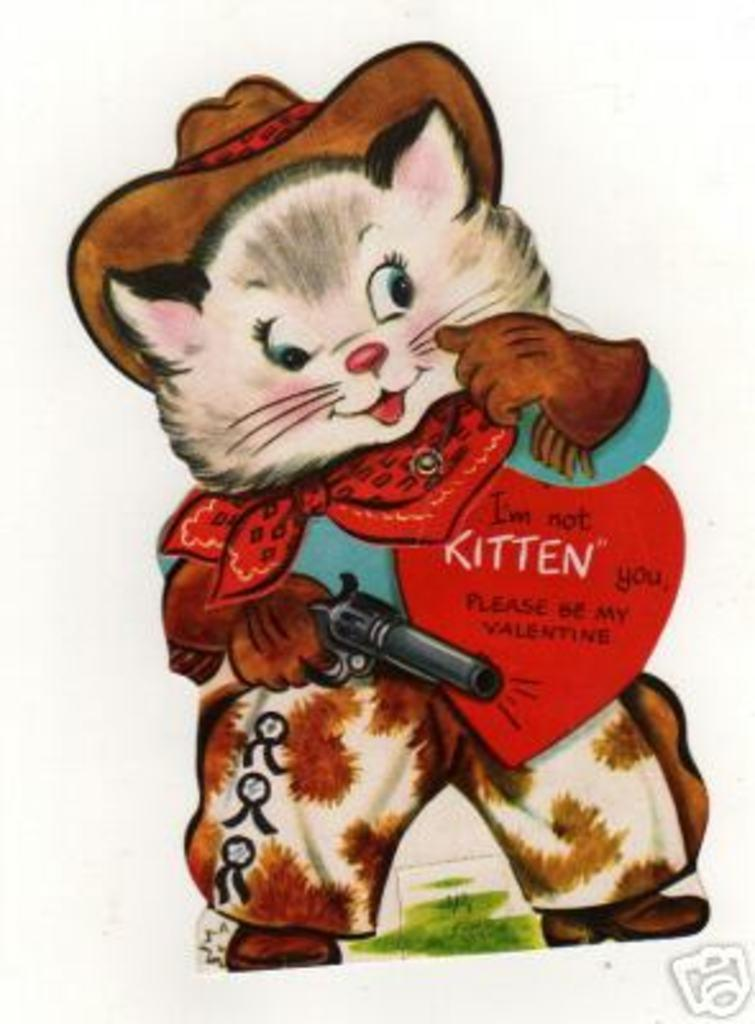What type of character is depicted in the image? There is a cartoon character in the image. What is the cartoon character holding? The cartoon character is holding a gun. What type of space thing is being powered by steam in the image? There is no space thing or steam present in the image; it features a cartoon character holding a gun. 